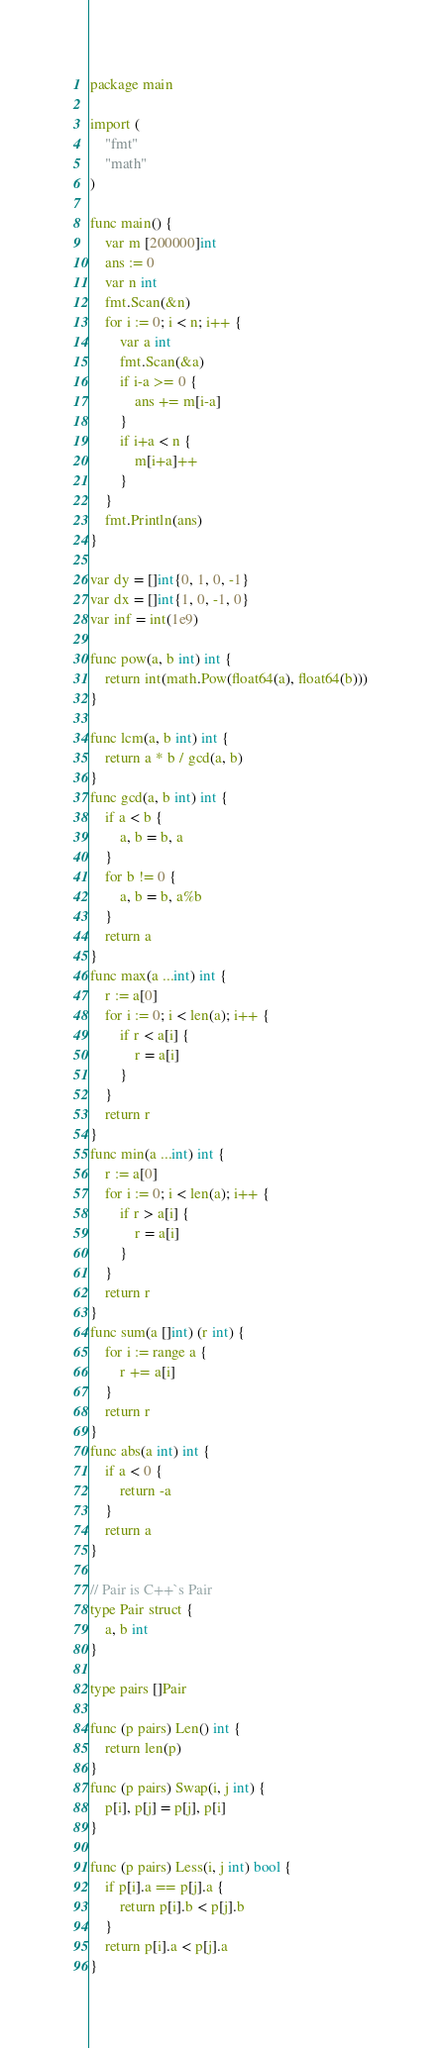Convert code to text. <code><loc_0><loc_0><loc_500><loc_500><_Go_>package main

import (
	"fmt"
	"math"
)

func main() {
	var m [200000]int
	ans := 0
	var n int
	fmt.Scan(&n)
	for i := 0; i < n; i++ {
		var a int
		fmt.Scan(&a)
		if i-a >= 0 {
			ans += m[i-a]
		}
		if i+a < n {
			m[i+a]++
		}
	}
	fmt.Println(ans)
}

var dy = []int{0, 1, 0, -1}
var dx = []int{1, 0, -1, 0}
var inf = int(1e9)

func pow(a, b int) int {
	return int(math.Pow(float64(a), float64(b)))
}

func lcm(a, b int) int {
	return a * b / gcd(a, b)
}
func gcd(a, b int) int {
	if a < b {
		a, b = b, a
	}
	for b != 0 {
		a, b = b, a%b
	}
	return a
}
func max(a ...int) int {
	r := a[0]
	for i := 0; i < len(a); i++ {
		if r < a[i] {
			r = a[i]
		}
	}
	return r
}
func min(a ...int) int {
	r := a[0]
	for i := 0; i < len(a); i++ {
		if r > a[i] {
			r = a[i]
		}
	}
	return r
}
func sum(a []int) (r int) {
	for i := range a {
		r += a[i]
	}
	return r
}
func abs(a int) int {
	if a < 0 {
		return -a
	}
	return a
}

// Pair is C++`s Pair
type Pair struct {
	a, b int
}

type pairs []Pair

func (p pairs) Len() int {
	return len(p)
}
func (p pairs) Swap(i, j int) {
	p[i], p[j] = p[j], p[i]
}

func (p pairs) Less(i, j int) bool {
	if p[i].a == p[j].a {
		return p[i].b < p[j].b
	}
	return p[i].a < p[j].a
}
</code> 